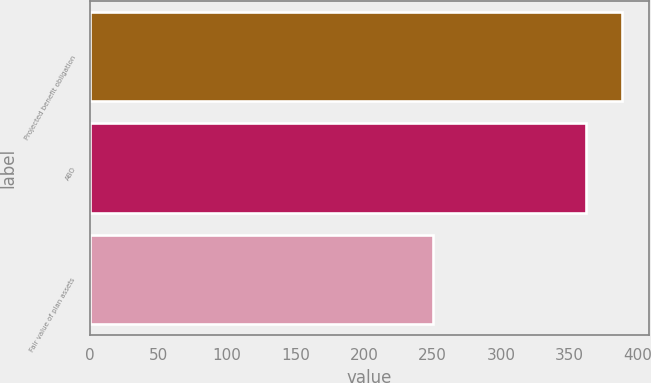Convert chart to OTSL. <chart><loc_0><loc_0><loc_500><loc_500><bar_chart><fcel>Projected benefit obligation<fcel>ABO<fcel>Fair value of plan assets<nl><fcel>388.5<fcel>361.6<fcel>250<nl></chart> 